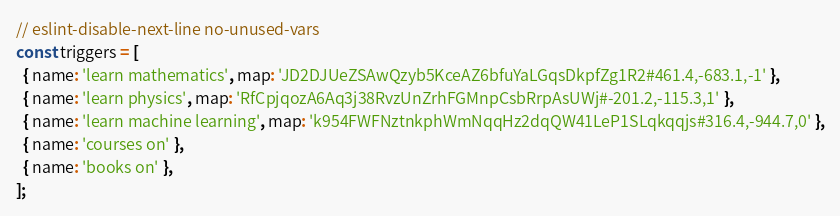Convert code to text. <code><loc_0><loc_0><loc_500><loc_500><_JavaScript_>// eslint-disable-next-line no-unused-vars
const triggers = [
  { name: 'learn mathematics', map: 'JD2DJUeZSAwQzyb5KceAZ6bfuYaLGqsDkpfZg1R2#461.4,-683.1,-1' },
  { name: 'learn physics', map: 'RfCpjqozA6Aq3j38RvzUnZrhFGMnpCsbRrpAsUWj#-201.2,-115.3,1' },
  { name: 'learn machine learning', map: 'k954FWFNztnkphWmNqqHz2dqQW41LeP1SLqkqqjs#316.4,-944.7,0' },
  { name: 'courses on' },
  { name: 'books on' },
];
</code> 